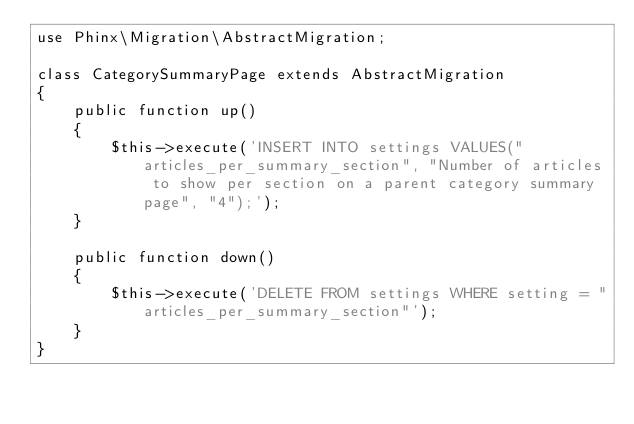<code> <loc_0><loc_0><loc_500><loc_500><_PHP_>use Phinx\Migration\AbstractMigration;

class CategorySummaryPage extends AbstractMigration
{
    public function up()
    {
        $this->execute('INSERT INTO settings VALUES("articles_per_summary_section", "Number of articles to show per section on a parent category summary page", "4");');
    }

    public function down()
    {
        $this->execute('DELETE FROM settings WHERE setting = "articles_per_summary_section"');
    }
}
</code> 